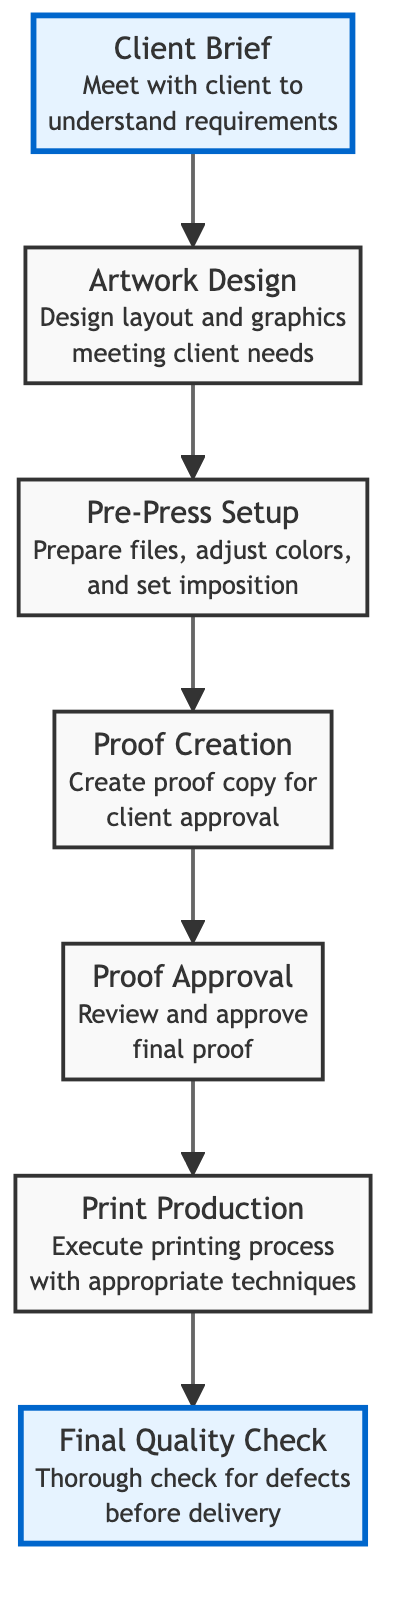What is the first step in the workflow? According to the diagram, the first step is "Client Brief," which indicates the initiation of the workflow by meeting with the client to understand their requirements.
Answer: Client Brief How many steps are there in this workflow? By counting all the nodes in the diagram from "Client Brief" to "Final Quality Check", there are a total of seven steps in the workflow.
Answer: Seven What is the last step in the workflow? The last step as seen in the diagram is "Final Quality Check," which involves a review of the printed materials before delivery.
Answer: Final Quality Check Which step follows the "Proof Creation"? The diagram shows that "Proof Approval" directly follows "Proof Creation," indicating the process of checking the proof created for client approval.
Answer: Proof Approval What is the relationship between "Print Production" and "Proof Approval"? The diagram indicates that "Print Production" occurs after "Proof Approval," so the relationship is sequential; essentially, printing happens after the proof has been approved.
Answer: Sequential What step involves adjusting digital files? The step that involves preparing and adjusting digital files is "Pre-Press Setup," where necessary adjustments for printing occur.
Answer: Pre-Press Setup How many approvals are done before printing? There is one approval, which is "Proof Approval," that must be completed before moving on to "Print Production" as depicted in the flow of the diagram.
Answer: One 